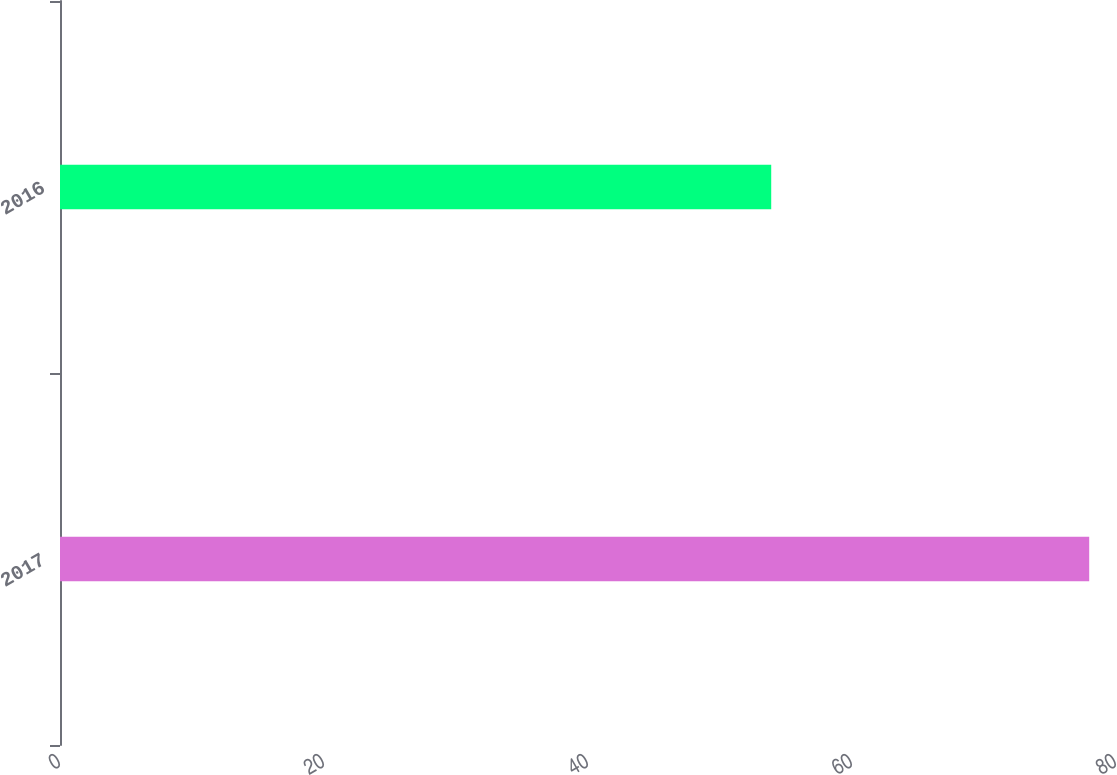Convert chart to OTSL. <chart><loc_0><loc_0><loc_500><loc_500><bar_chart><fcel>2017<fcel>2016<nl><fcel>77.97<fcel>53.88<nl></chart> 